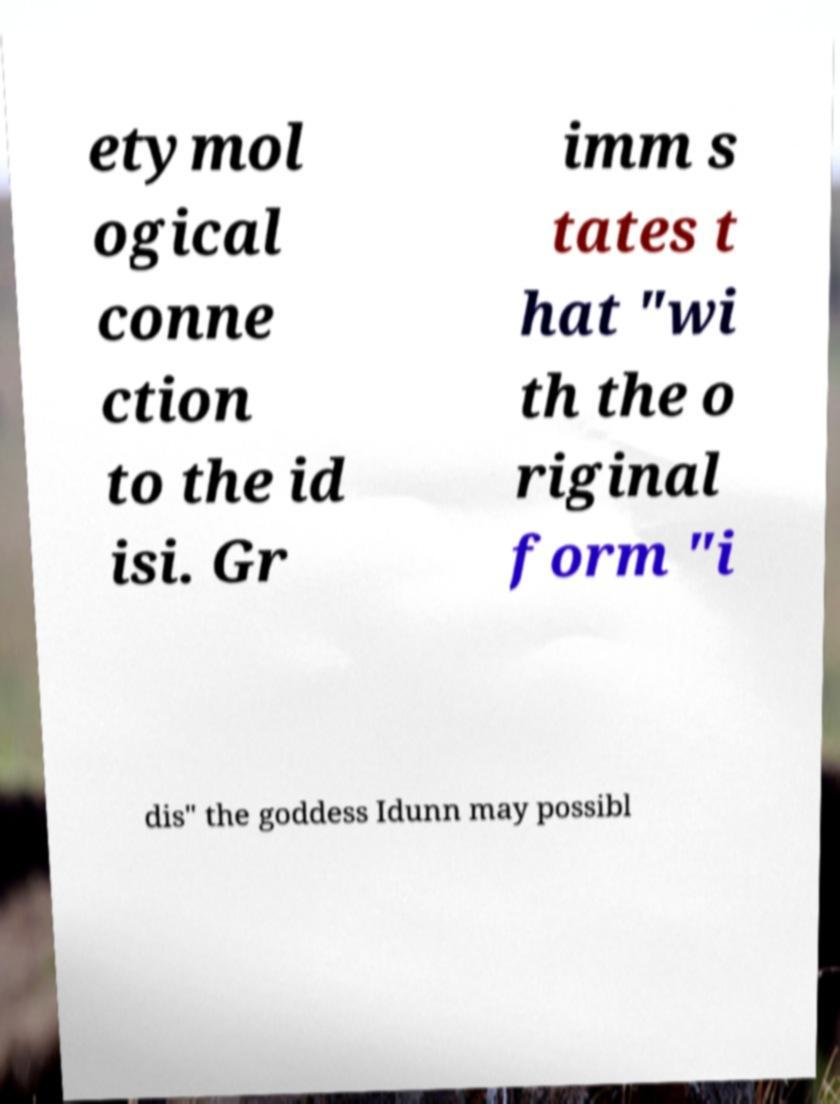Could you assist in decoding the text presented in this image and type it out clearly? etymol ogical conne ction to the id isi. Gr imm s tates t hat "wi th the o riginal form "i dis" the goddess Idunn may possibl 